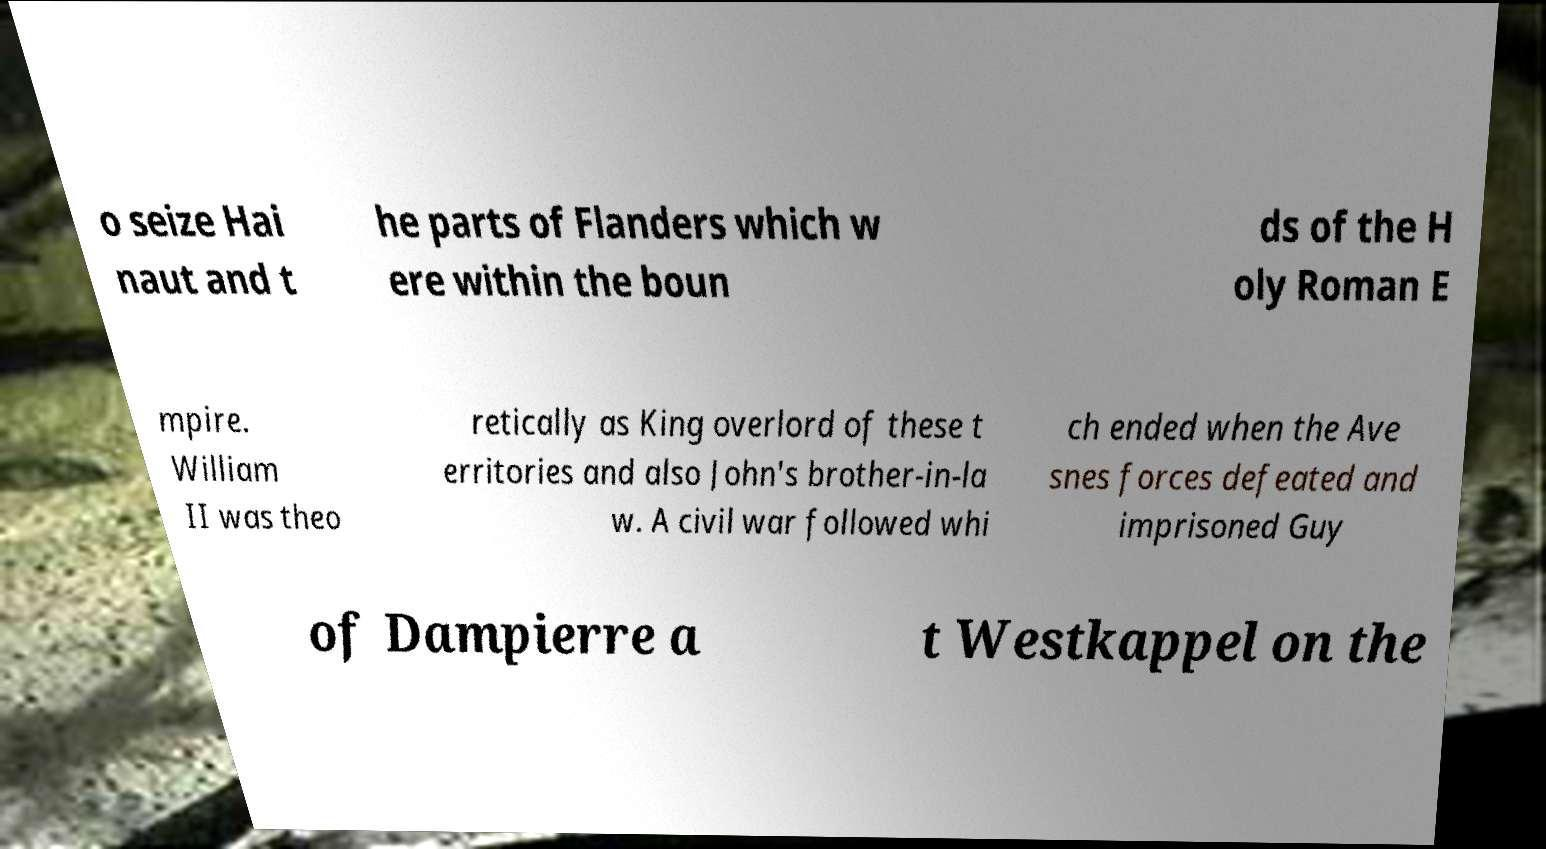Could you extract and type out the text from this image? o seize Hai naut and t he parts of Flanders which w ere within the boun ds of the H oly Roman E mpire. William II was theo retically as King overlord of these t erritories and also John's brother-in-la w. A civil war followed whi ch ended when the Ave snes forces defeated and imprisoned Guy of Dampierre a t Westkappel on the 